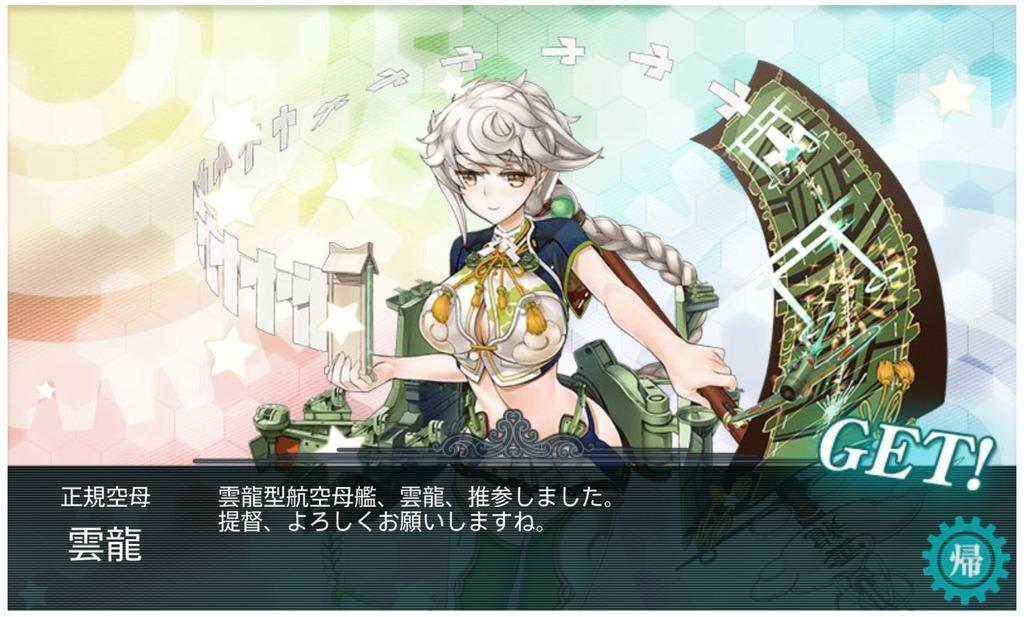Please provide a concise description of this image. This is an animated image. I can see a girl holding the objects. At the bottom of the image, there is some text and a logo on the image. 